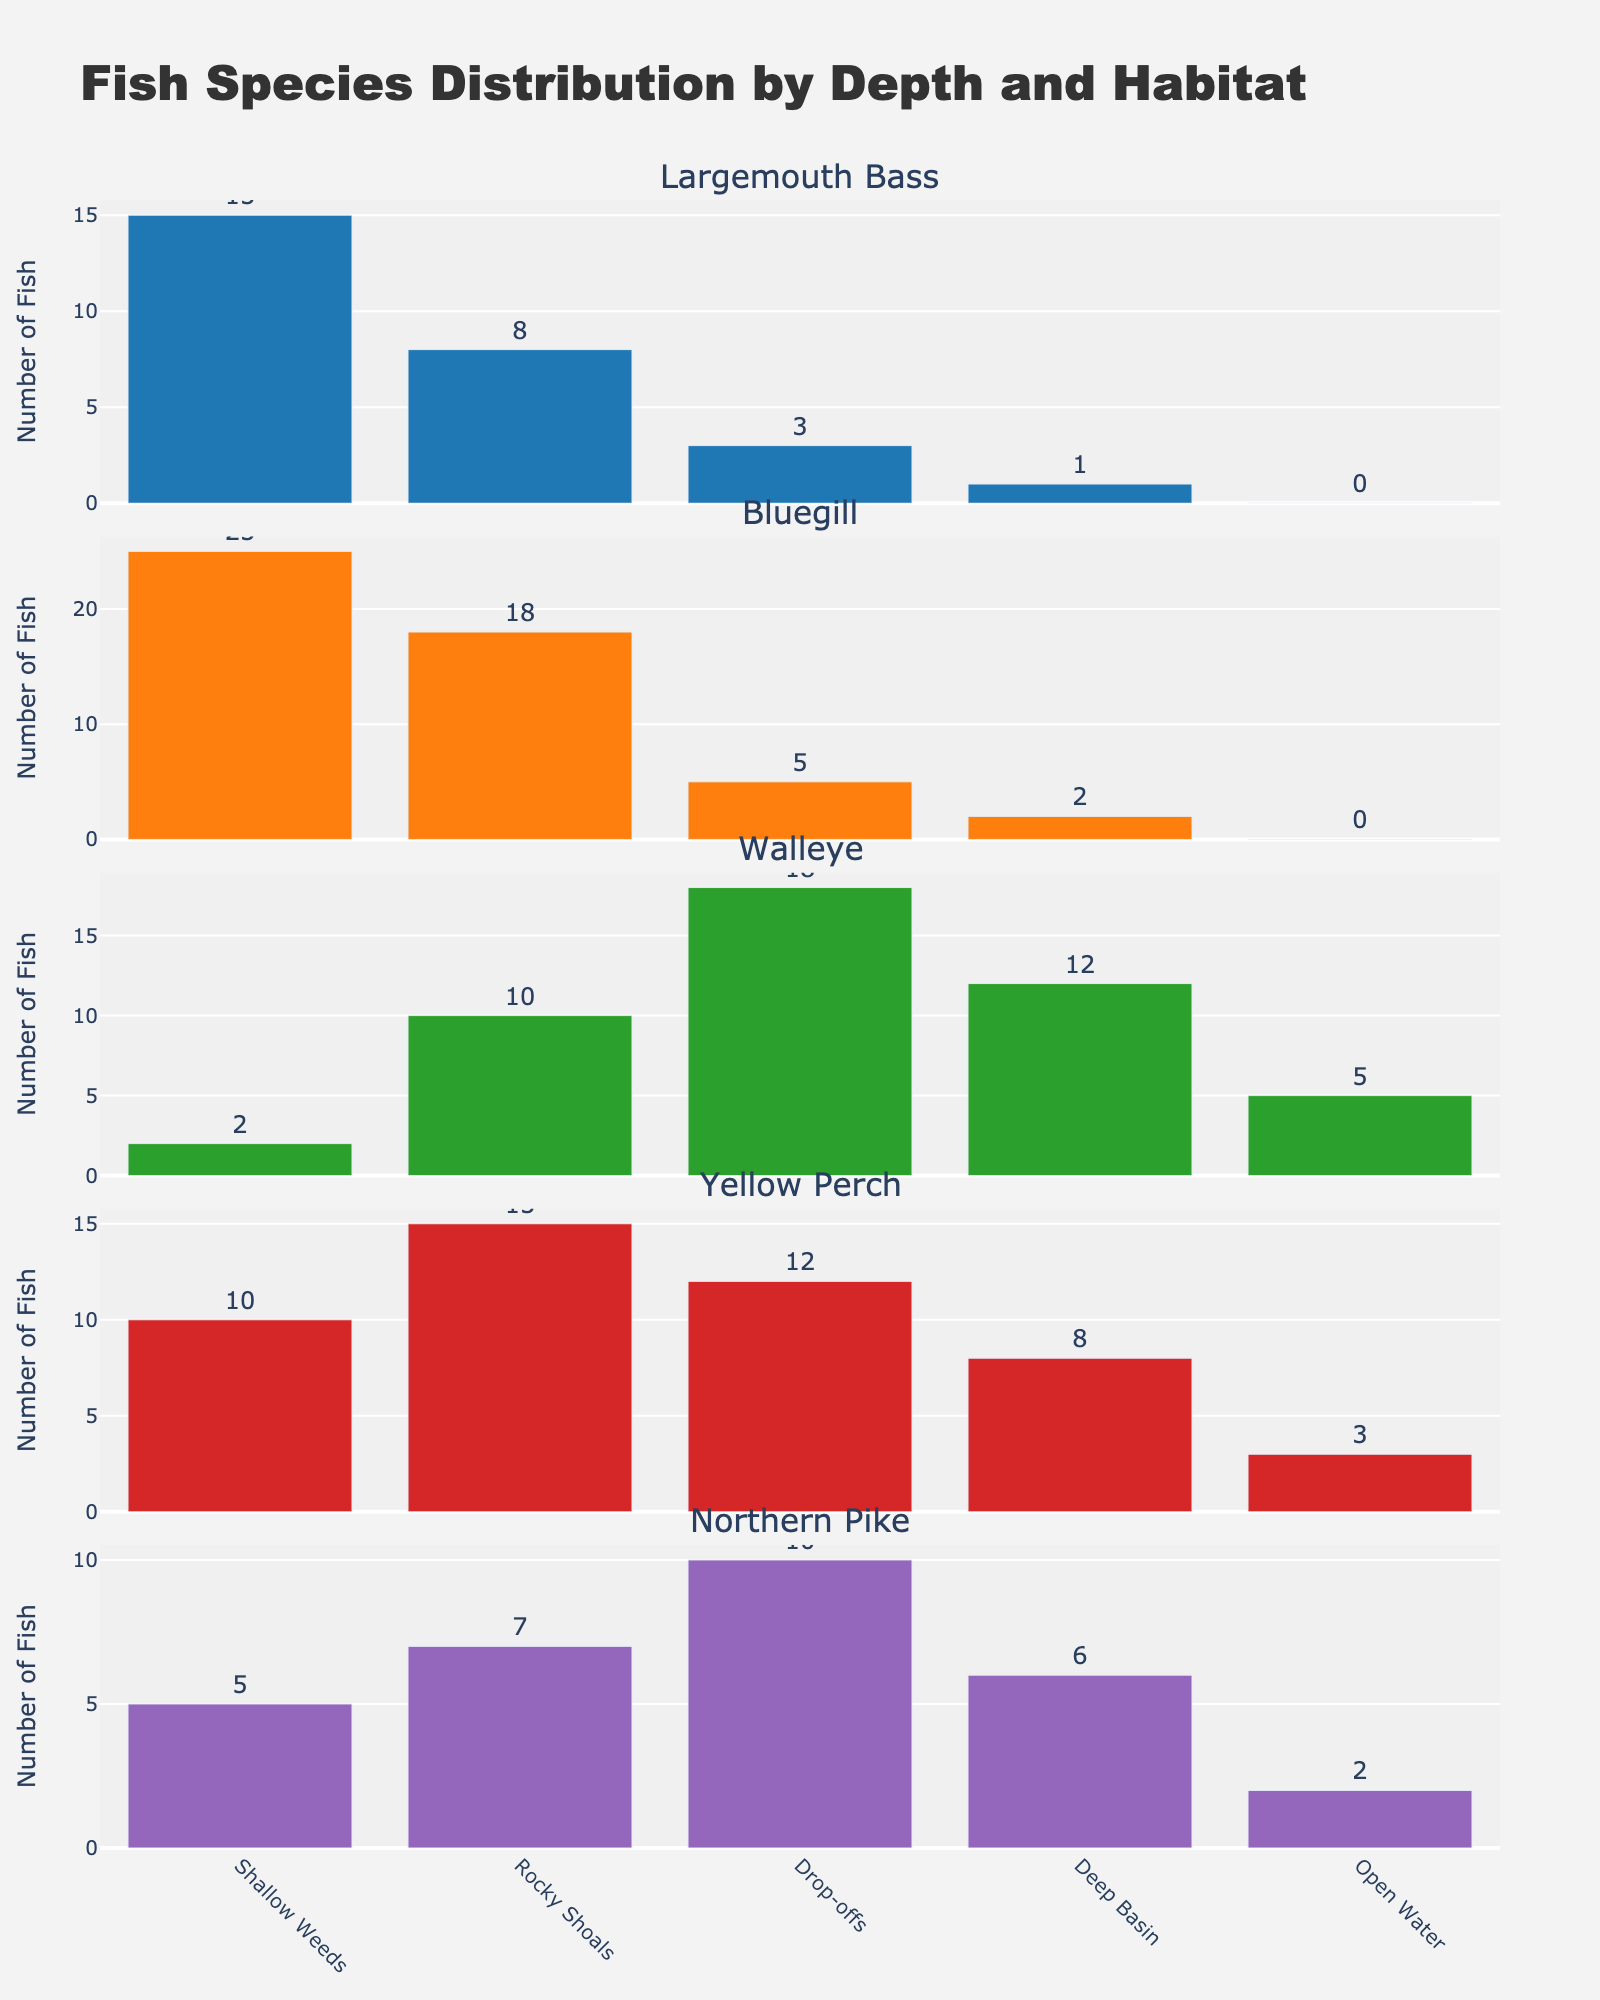What is the title of the figure? The title is displayed at the top of the figure in a larger and bolder font compared to other text elements. It gives an overview of what the figure represents.
Answer: Fish Species Distribution by Depth and Habitat How many habitats are listed in the figure? To find the number of habitats, count the unique habitat labels on the x-axis of any subplot. These labels represent different depths where fish species have been observed.
Answer: 5 Which fish species is most frequently found in the 'Shallow Weeds' habitat? Look at the bar heights in the subplot corresponding to 'Shallow Weeds'. The tallest bar indicates the most frequent fish species in that habitat.
Answer: Bluegill Across all habitats, which fish species has the highest average number? Calculate the average for each fish species by summing their counts across all habitats and then dividing by the number of habitats. Compare all these averages to identify the highest one.
Answer: Yellow Perch Which habitat shows the highest number of Largemouth Bass? Focus on the subplot for Largemouth Bass and compare the heights of the bars. The tallest bar indicates the habitat with the highest number.
Answer: Shallow Weeds How does the distribution of Northern Pike vary with depth? Examine the subplot for Northern Pike and observe the bar heights. Note the variation in bar heights across different habitats that represent various depths.
Answer: Decreases with depth In which habitat is the count of Walleye greater than Bluegill? Compare the bar heights of Walleye and Bluegill in each habitat's subplots. Identify the habitats where Walleye's bar is taller than Bluegill's.
Answer: Drop-offs What is the total number of Yellow Perch across all habitats? Sum the bar heights for Yellow Perch from each subplot.
Answer: 48 Which fish species is least common in the ‘Deep Basin’ habitat? Look at the subplot for the ‘Deep Basin’ habitat and find the shortest bar. This indicates the least common species.
Answer: Bluegill Compare the numbers of Largemouth Bass and Walleye in the 'Rocky Shoals' habitat. Which one has more fish? In the subplot for 'Rocky Shoals', compare the bars for Largemouth Bass and Walleye. The taller bar indicates the species with a higher number of fish.
Answer: Walleye 